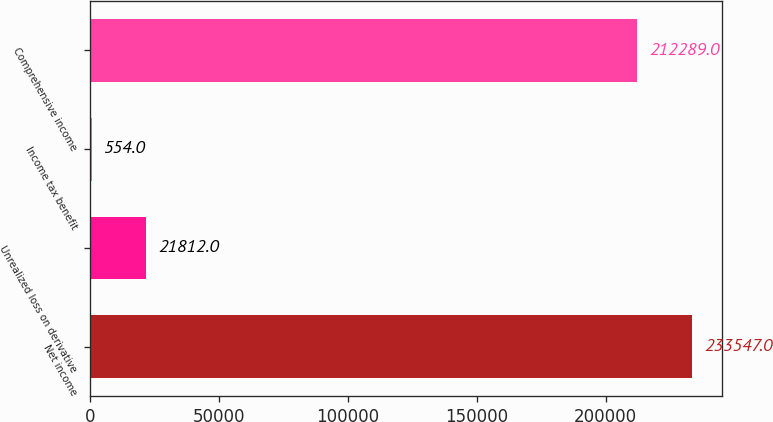<chart> <loc_0><loc_0><loc_500><loc_500><bar_chart><fcel>Net income<fcel>Unrealized loss on derivative<fcel>Income tax benefit<fcel>Comprehensive income<nl><fcel>233547<fcel>21812<fcel>554<fcel>212289<nl></chart> 